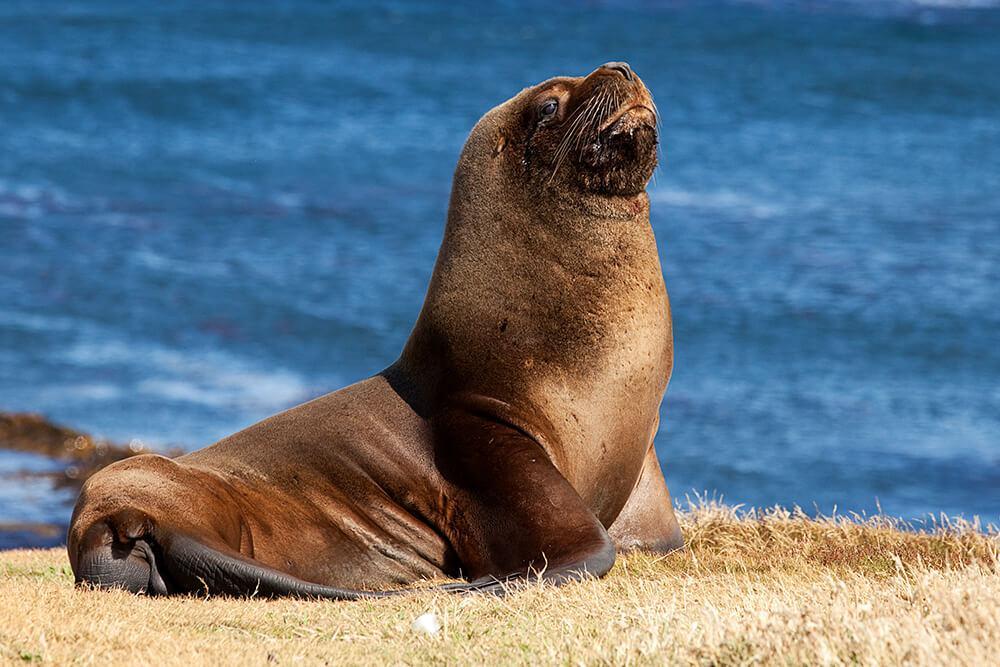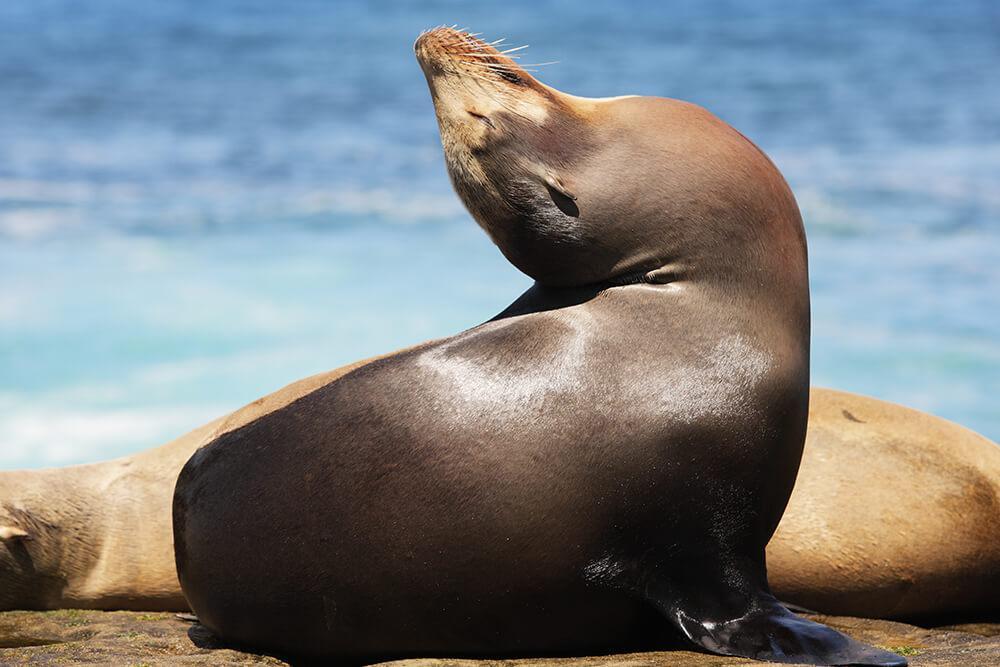The first image is the image on the left, the second image is the image on the right. Assess this claim about the two images: "No image shows more than two seals.". Correct or not? Answer yes or no. Yes. 